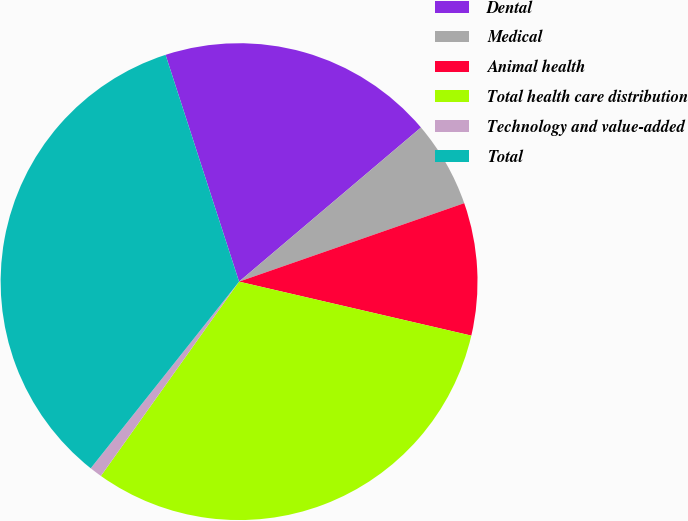Convert chart. <chart><loc_0><loc_0><loc_500><loc_500><pie_chart><fcel>Dental<fcel>Medical<fcel>Animal health<fcel>Total health care distribution<fcel>Technology and value-added<fcel>Total<nl><fcel>18.8%<fcel>5.85%<fcel>8.97%<fcel>31.2%<fcel>0.85%<fcel>34.32%<nl></chart> 